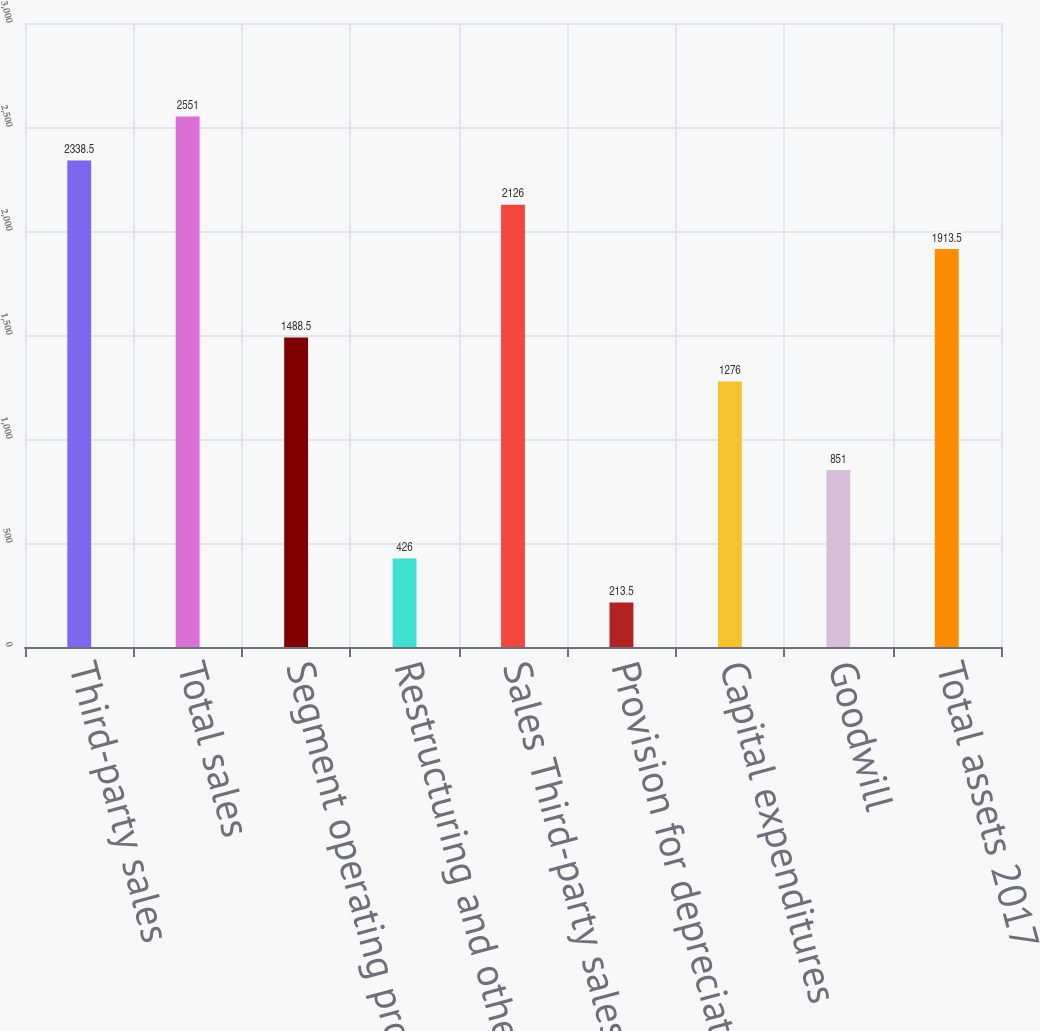Convert chart. <chart><loc_0><loc_0><loc_500><loc_500><bar_chart><fcel>Third-party sales<fcel>Total sales<fcel>Segment operating profit<fcel>Restructuring and other<fcel>Sales Third-party sales<fcel>Provision for depreciation and<fcel>Capital expenditures<fcel>Goodwill<fcel>Total assets 2017<nl><fcel>2338.5<fcel>2551<fcel>1488.5<fcel>426<fcel>2126<fcel>213.5<fcel>1276<fcel>851<fcel>1913.5<nl></chart> 